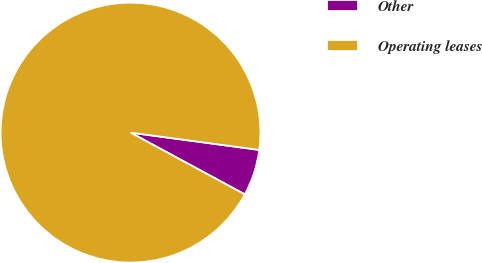Convert chart to OTSL. <chart><loc_0><loc_0><loc_500><loc_500><pie_chart><fcel>Other<fcel>Operating leases<nl><fcel>5.76%<fcel>94.24%<nl></chart> 